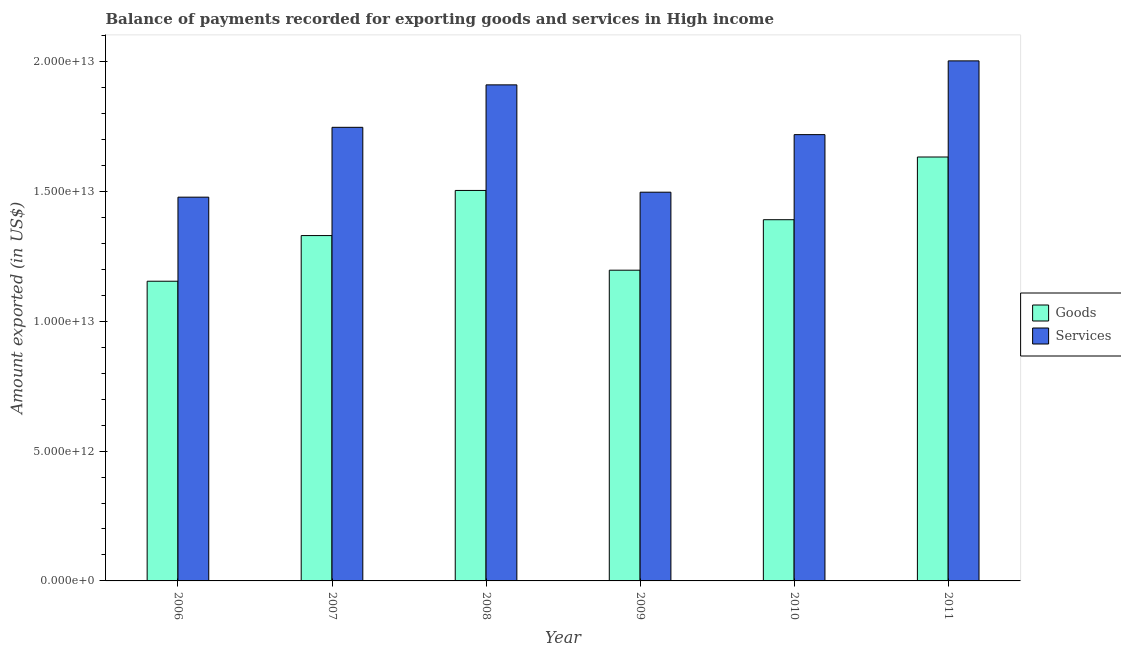Are the number of bars on each tick of the X-axis equal?
Your answer should be compact. Yes. How many bars are there on the 5th tick from the left?
Provide a succinct answer. 2. How many bars are there on the 1st tick from the right?
Your response must be concise. 2. What is the label of the 6th group of bars from the left?
Provide a succinct answer. 2011. In how many cases, is the number of bars for a given year not equal to the number of legend labels?
Your response must be concise. 0. What is the amount of goods exported in 2008?
Make the answer very short. 1.50e+13. Across all years, what is the maximum amount of goods exported?
Provide a succinct answer. 1.63e+13. Across all years, what is the minimum amount of goods exported?
Give a very brief answer. 1.15e+13. In which year was the amount of services exported minimum?
Provide a short and direct response. 2006. What is the total amount of goods exported in the graph?
Offer a terse response. 8.21e+13. What is the difference between the amount of services exported in 2009 and that in 2011?
Provide a short and direct response. -5.06e+12. What is the difference between the amount of services exported in 2011 and the amount of goods exported in 2009?
Ensure brevity in your answer.  5.06e+12. What is the average amount of goods exported per year?
Your answer should be compact. 1.37e+13. In the year 2006, what is the difference between the amount of services exported and amount of goods exported?
Your answer should be very brief. 0. In how many years, is the amount of services exported greater than 14000000000000 US$?
Offer a terse response. 6. What is the ratio of the amount of goods exported in 2006 to that in 2010?
Offer a very short reply. 0.83. What is the difference between the highest and the second highest amount of goods exported?
Your response must be concise. 1.29e+12. What is the difference between the highest and the lowest amount of goods exported?
Give a very brief answer. 4.78e+12. What does the 1st bar from the left in 2008 represents?
Your answer should be very brief. Goods. What does the 2nd bar from the right in 2006 represents?
Your answer should be compact. Goods. What is the difference between two consecutive major ticks on the Y-axis?
Your response must be concise. 5.00e+12. Are the values on the major ticks of Y-axis written in scientific E-notation?
Your response must be concise. Yes. Where does the legend appear in the graph?
Provide a succinct answer. Center right. How are the legend labels stacked?
Keep it short and to the point. Vertical. What is the title of the graph?
Keep it short and to the point. Balance of payments recorded for exporting goods and services in High income. What is the label or title of the X-axis?
Make the answer very short. Year. What is the label or title of the Y-axis?
Keep it short and to the point. Amount exported (in US$). What is the Amount exported (in US$) of Goods in 2006?
Provide a short and direct response. 1.15e+13. What is the Amount exported (in US$) of Services in 2006?
Your answer should be compact. 1.48e+13. What is the Amount exported (in US$) in Goods in 2007?
Provide a succinct answer. 1.33e+13. What is the Amount exported (in US$) of Services in 2007?
Keep it short and to the point. 1.75e+13. What is the Amount exported (in US$) in Goods in 2008?
Your response must be concise. 1.50e+13. What is the Amount exported (in US$) of Services in 2008?
Keep it short and to the point. 1.91e+13. What is the Amount exported (in US$) in Goods in 2009?
Your answer should be compact. 1.20e+13. What is the Amount exported (in US$) in Services in 2009?
Ensure brevity in your answer.  1.50e+13. What is the Amount exported (in US$) of Goods in 2010?
Your response must be concise. 1.39e+13. What is the Amount exported (in US$) of Services in 2010?
Keep it short and to the point. 1.72e+13. What is the Amount exported (in US$) of Goods in 2011?
Your answer should be compact. 1.63e+13. What is the Amount exported (in US$) in Services in 2011?
Keep it short and to the point. 2.00e+13. Across all years, what is the maximum Amount exported (in US$) in Goods?
Make the answer very short. 1.63e+13. Across all years, what is the maximum Amount exported (in US$) of Services?
Provide a succinct answer. 2.00e+13. Across all years, what is the minimum Amount exported (in US$) in Goods?
Provide a succinct answer. 1.15e+13. Across all years, what is the minimum Amount exported (in US$) of Services?
Offer a terse response. 1.48e+13. What is the total Amount exported (in US$) of Goods in the graph?
Give a very brief answer. 8.21e+13. What is the total Amount exported (in US$) in Services in the graph?
Give a very brief answer. 1.04e+14. What is the difference between the Amount exported (in US$) in Goods in 2006 and that in 2007?
Offer a very short reply. -1.76e+12. What is the difference between the Amount exported (in US$) of Services in 2006 and that in 2007?
Provide a succinct answer. -2.69e+12. What is the difference between the Amount exported (in US$) of Goods in 2006 and that in 2008?
Make the answer very short. -3.50e+12. What is the difference between the Amount exported (in US$) of Services in 2006 and that in 2008?
Your response must be concise. -4.32e+12. What is the difference between the Amount exported (in US$) in Goods in 2006 and that in 2009?
Your response must be concise. -4.24e+11. What is the difference between the Amount exported (in US$) in Services in 2006 and that in 2009?
Provide a succinct answer. -1.91e+11. What is the difference between the Amount exported (in US$) of Goods in 2006 and that in 2010?
Your answer should be very brief. -2.37e+12. What is the difference between the Amount exported (in US$) of Services in 2006 and that in 2010?
Offer a terse response. -2.41e+12. What is the difference between the Amount exported (in US$) in Goods in 2006 and that in 2011?
Your answer should be very brief. -4.78e+12. What is the difference between the Amount exported (in US$) of Services in 2006 and that in 2011?
Your answer should be very brief. -5.25e+12. What is the difference between the Amount exported (in US$) in Goods in 2007 and that in 2008?
Provide a short and direct response. -1.74e+12. What is the difference between the Amount exported (in US$) in Services in 2007 and that in 2008?
Provide a succinct answer. -1.63e+12. What is the difference between the Amount exported (in US$) of Goods in 2007 and that in 2009?
Provide a short and direct response. 1.33e+12. What is the difference between the Amount exported (in US$) in Services in 2007 and that in 2009?
Your answer should be compact. 2.50e+12. What is the difference between the Amount exported (in US$) of Goods in 2007 and that in 2010?
Your response must be concise. -6.11e+11. What is the difference between the Amount exported (in US$) of Services in 2007 and that in 2010?
Your response must be concise. 2.81e+11. What is the difference between the Amount exported (in US$) of Goods in 2007 and that in 2011?
Provide a short and direct response. -3.03e+12. What is the difference between the Amount exported (in US$) of Services in 2007 and that in 2011?
Make the answer very short. -2.56e+12. What is the difference between the Amount exported (in US$) in Goods in 2008 and that in 2009?
Make the answer very short. 3.07e+12. What is the difference between the Amount exported (in US$) of Services in 2008 and that in 2009?
Your response must be concise. 4.13e+12. What is the difference between the Amount exported (in US$) of Goods in 2008 and that in 2010?
Provide a succinct answer. 1.13e+12. What is the difference between the Amount exported (in US$) of Services in 2008 and that in 2010?
Keep it short and to the point. 1.92e+12. What is the difference between the Amount exported (in US$) in Goods in 2008 and that in 2011?
Give a very brief answer. -1.29e+12. What is the difference between the Amount exported (in US$) in Services in 2008 and that in 2011?
Keep it short and to the point. -9.24e+11. What is the difference between the Amount exported (in US$) in Goods in 2009 and that in 2010?
Keep it short and to the point. -1.94e+12. What is the difference between the Amount exported (in US$) in Services in 2009 and that in 2010?
Your answer should be very brief. -2.22e+12. What is the difference between the Amount exported (in US$) of Goods in 2009 and that in 2011?
Make the answer very short. -4.36e+12. What is the difference between the Amount exported (in US$) of Services in 2009 and that in 2011?
Your answer should be compact. -5.06e+12. What is the difference between the Amount exported (in US$) in Goods in 2010 and that in 2011?
Give a very brief answer. -2.41e+12. What is the difference between the Amount exported (in US$) of Services in 2010 and that in 2011?
Ensure brevity in your answer.  -2.84e+12. What is the difference between the Amount exported (in US$) of Goods in 2006 and the Amount exported (in US$) of Services in 2007?
Make the answer very short. -5.93e+12. What is the difference between the Amount exported (in US$) of Goods in 2006 and the Amount exported (in US$) of Services in 2008?
Provide a short and direct response. -7.56e+12. What is the difference between the Amount exported (in US$) of Goods in 2006 and the Amount exported (in US$) of Services in 2009?
Offer a terse response. -3.43e+12. What is the difference between the Amount exported (in US$) of Goods in 2006 and the Amount exported (in US$) of Services in 2010?
Make the answer very short. -5.65e+12. What is the difference between the Amount exported (in US$) of Goods in 2006 and the Amount exported (in US$) of Services in 2011?
Your response must be concise. -8.49e+12. What is the difference between the Amount exported (in US$) in Goods in 2007 and the Amount exported (in US$) in Services in 2008?
Offer a terse response. -5.80e+12. What is the difference between the Amount exported (in US$) of Goods in 2007 and the Amount exported (in US$) of Services in 2009?
Your answer should be compact. -1.67e+12. What is the difference between the Amount exported (in US$) in Goods in 2007 and the Amount exported (in US$) in Services in 2010?
Provide a succinct answer. -3.89e+12. What is the difference between the Amount exported (in US$) in Goods in 2007 and the Amount exported (in US$) in Services in 2011?
Keep it short and to the point. -6.73e+12. What is the difference between the Amount exported (in US$) in Goods in 2008 and the Amount exported (in US$) in Services in 2009?
Provide a short and direct response. 6.79e+1. What is the difference between the Amount exported (in US$) in Goods in 2008 and the Amount exported (in US$) in Services in 2010?
Give a very brief answer. -2.15e+12. What is the difference between the Amount exported (in US$) in Goods in 2008 and the Amount exported (in US$) in Services in 2011?
Your answer should be compact. -4.99e+12. What is the difference between the Amount exported (in US$) of Goods in 2009 and the Amount exported (in US$) of Services in 2010?
Give a very brief answer. -5.22e+12. What is the difference between the Amount exported (in US$) in Goods in 2009 and the Amount exported (in US$) in Services in 2011?
Make the answer very short. -8.06e+12. What is the difference between the Amount exported (in US$) in Goods in 2010 and the Amount exported (in US$) in Services in 2011?
Offer a terse response. -6.12e+12. What is the average Amount exported (in US$) in Goods per year?
Ensure brevity in your answer.  1.37e+13. What is the average Amount exported (in US$) of Services per year?
Your answer should be compact. 1.73e+13. In the year 2006, what is the difference between the Amount exported (in US$) in Goods and Amount exported (in US$) in Services?
Offer a terse response. -3.24e+12. In the year 2007, what is the difference between the Amount exported (in US$) in Goods and Amount exported (in US$) in Services?
Keep it short and to the point. -4.17e+12. In the year 2008, what is the difference between the Amount exported (in US$) in Goods and Amount exported (in US$) in Services?
Offer a very short reply. -4.07e+12. In the year 2009, what is the difference between the Amount exported (in US$) in Goods and Amount exported (in US$) in Services?
Your response must be concise. -3.00e+12. In the year 2010, what is the difference between the Amount exported (in US$) of Goods and Amount exported (in US$) of Services?
Keep it short and to the point. -3.28e+12. In the year 2011, what is the difference between the Amount exported (in US$) of Goods and Amount exported (in US$) of Services?
Give a very brief answer. -3.70e+12. What is the ratio of the Amount exported (in US$) in Goods in 2006 to that in 2007?
Ensure brevity in your answer.  0.87. What is the ratio of the Amount exported (in US$) of Services in 2006 to that in 2007?
Provide a succinct answer. 0.85. What is the ratio of the Amount exported (in US$) of Goods in 2006 to that in 2008?
Your answer should be very brief. 0.77. What is the ratio of the Amount exported (in US$) in Services in 2006 to that in 2008?
Make the answer very short. 0.77. What is the ratio of the Amount exported (in US$) in Goods in 2006 to that in 2009?
Provide a short and direct response. 0.96. What is the ratio of the Amount exported (in US$) in Services in 2006 to that in 2009?
Provide a short and direct response. 0.99. What is the ratio of the Amount exported (in US$) in Goods in 2006 to that in 2010?
Give a very brief answer. 0.83. What is the ratio of the Amount exported (in US$) in Services in 2006 to that in 2010?
Keep it short and to the point. 0.86. What is the ratio of the Amount exported (in US$) in Goods in 2006 to that in 2011?
Offer a terse response. 0.71. What is the ratio of the Amount exported (in US$) of Services in 2006 to that in 2011?
Provide a short and direct response. 0.74. What is the ratio of the Amount exported (in US$) of Goods in 2007 to that in 2008?
Your answer should be compact. 0.88. What is the ratio of the Amount exported (in US$) in Services in 2007 to that in 2008?
Your answer should be compact. 0.91. What is the ratio of the Amount exported (in US$) in Goods in 2007 to that in 2009?
Provide a succinct answer. 1.11. What is the ratio of the Amount exported (in US$) in Services in 2007 to that in 2009?
Provide a short and direct response. 1.17. What is the ratio of the Amount exported (in US$) of Goods in 2007 to that in 2010?
Keep it short and to the point. 0.96. What is the ratio of the Amount exported (in US$) in Services in 2007 to that in 2010?
Your answer should be compact. 1.02. What is the ratio of the Amount exported (in US$) of Goods in 2007 to that in 2011?
Provide a succinct answer. 0.81. What is the ratio of the Amount exported (in US$) of Services in 2007 to that in 2011?
Provide a short and direct response. 0.87. What is the ratio of the Amount exported (in US$) of Goods in 2008 to that in 2009?
Give a very brief answer. 1.26. What is the ratio of the Amount exported (in US$) in Services in 2008 to that in 2009?
Make the answer very short. 1.28. What is the ratio of the Amount exported (in US$) in Goods in 2008 to that in 2010?
Make the answer very short. 1.08. What is the ratio of the Amount exported (in US$) in Services in 2008 to that in 2010?
Give a very brief answer. 1.11. What is the ratio of the Amount exported (in US$) of Goods in 2008 to that in 2011?
Keep it short and to the point. 0.92. What is the ratio of the Amount exported (in US$) in Services in 2008 to that in 2011?
Give a very brief answer. 0.95. What is the ratio of the Amount exported (in US$) in Goods in 2009 to that in 2010?
Make the answer very short. 0.86. What is the ratio of the Amount exported (in US$) in Services in 2009 to that in 2010?
Keep it short and to the point. 0.87. What is the ratio of the Amount exported (in US$) in Goods in 2009 to that in 2011?
Provide a short and direct response. 0.73. What is the ratio of the Amount exported (in US$) of Services in 2009 to that in 2011?
Make the answer very short. 0.75. What is the ratio of the Amount exported (in US$) of Goods in 2010 to that in 2011?
Your response must be concise. 0.85. What is the ratio of the Amount exported (in US$) of Services in 2010 to that in 2011?
Provide a succinct answer. 0.86. What is the difference between the highest and the second highest Amount exported (in US$) of Goods?
Make the answer very short. 1.29e+12. What is the difference between the highest and the second highest Amount exported (in US$) of Services?
Offer a very short reply. 9.24e+11. What is the difference between the highest and the lowest Amount exported (in US$) of Goods?
Keep it short and to the point. 4.78e+12. What is the difference between the highest and the lowest Amount exported (in US$) of Services?
Give a very brief answer. 5.25e+12. 